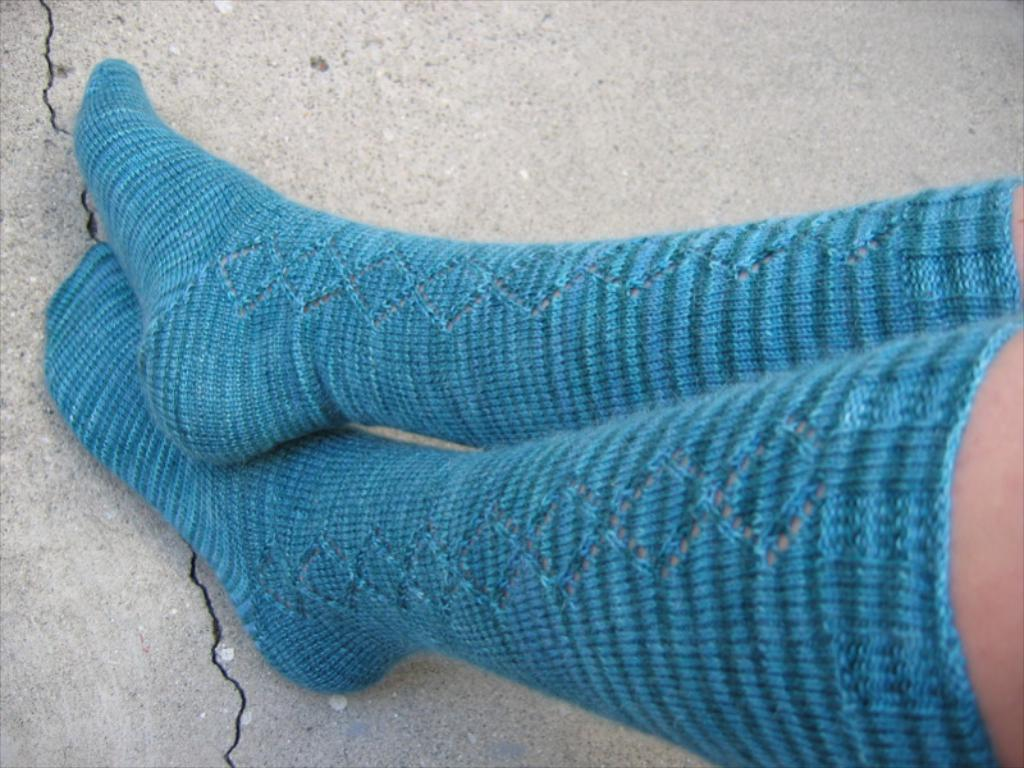What part of a person can be seen in the image? There are legs of a person visible in the image. What are the legs wearing? The legs are covered with socks. Where are the legs located? The legs are on the road. What type of railway can be seen in the image? There is no railway present in the image; it only shows legs of a person on the road. How deep is the cellar in the image? There is no cellar present in the image; it only shows legs of a person on the road. 